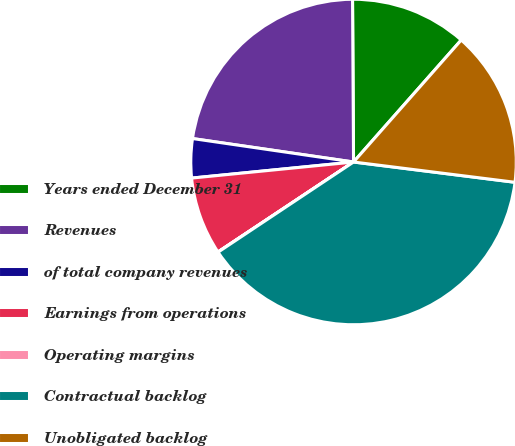<chart> <loc_0><loc_0><loc_500><loc_500><pie_chart><fcel>Years ended December 31<fcel>Revenues<fcel>of total company revenues<fcel>Earnings from operations<fcel>Operating margins<fcel>Contractual backlog<fcel>Unobligated backlog<nl><fcel>11.61%<fcel>22.6%<fcel>3.88%<fcel>7.75%<fcel>0.02%<fcel>38.67%<fcel>15.48%<nl></chart> 